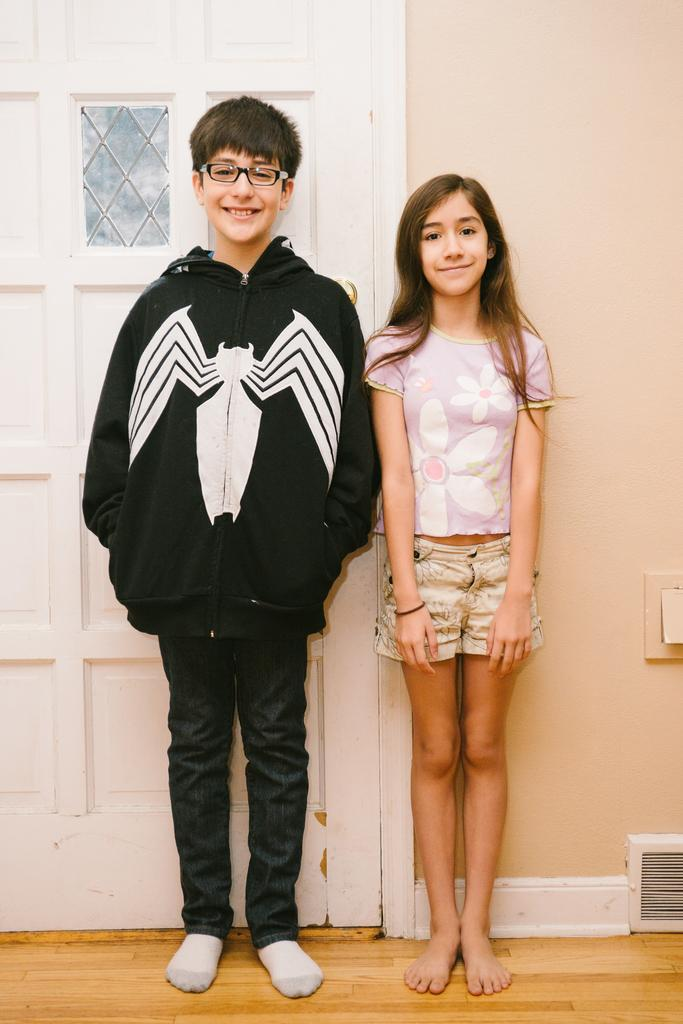Who are the people in the image? There is a boy and a girl in the image. What are the expressions on their faces? Both the boy and girl are smiling in the image. Where are they standing? They are standing on the floor in the image. What can be seen in the background of the image? There is a white door and a plain wall in the background of the image. What type of rod is being used by the boy to plot the end of the story? There is no rod or story plotting in the image; it simply features a boy and a girl smiling while standing on the floor. 